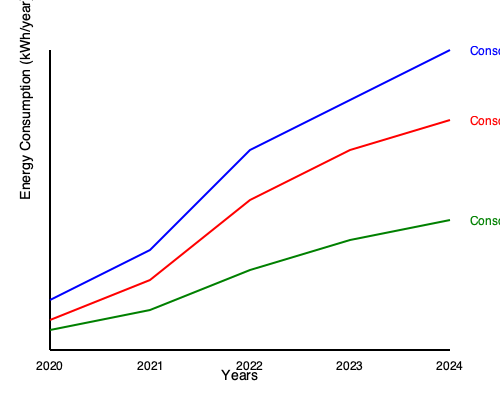The graph shows the annual energy consumption of three gaming consoles over five years. If the trend continues, by what percentage will Console A's energy consumption decrease from 2020 to 2025? To solve this problem, we need to follow these steps:

1. Identify Console A's energy consumption values:
   2020: ~250 kWh/year
   2024: ~150 kWh/year

2. Calculate the yearly rate of decrease:
   Decrease over 4 years = 250 - 150 = 100 kWh/year
   Yearly decrease = 100 ÷ 4 = 25 kWh/year

3. Extrapolate to 2025:
   2025 consumption = 150 - 25 = 125 kWh/year

4. Calculate the total decrease from 2020 to 2025:
   Total decrease = 250 - 125 = 125 kWh/year

5. Calculate the percentage decrease:
   Percentage decrease = (Decrease ÷ Original Value) × 100
   $$ \text{Percentage decrease} = \frac{125}{250} \times 100 = 50\% $$

Therefore, if the trend continues, Console A's energy consumption will decrease by 50% from 2020 to 2025.
Answer: 50% 